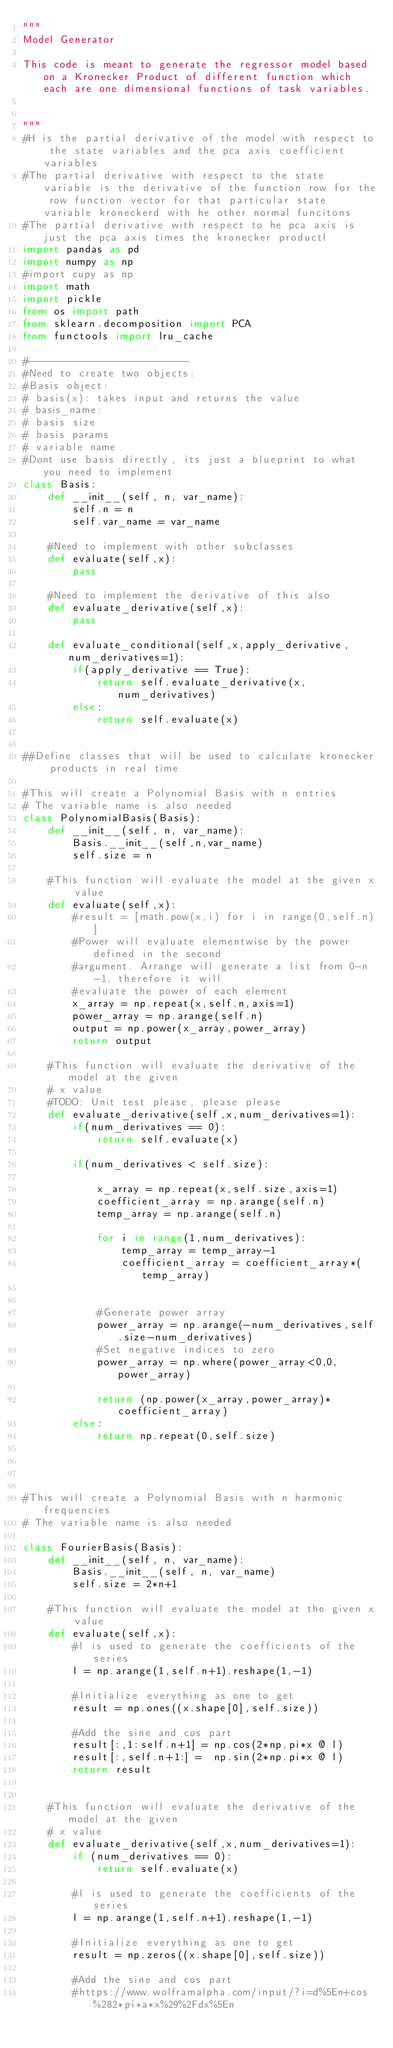Convert code to text. <code><loc_0><loc_0><loc_500><loc_500><_Python_>"""
Model Generator 

This code is meant to generate the regressor model based on a Kronecker Product of different function which each are one dimensional functions of task variables. 


"""
#H is the partial derivative of the model with respect to the state variables and the pca axis coefficient variables 
#The partial derivative with respect to the state variable is the derivative of the function row for the row function vector for that particular state variable kroneckerd with he other normal funcitons
#The partial derivative with respect to he pca axis is just the pca axis times the kronecker productl
import pandas as pd
import numpy as np
#import cupy as np
import math
import pickle
from os import path
from sklearn.decomposition import PCA
from functools import lru_cache

#--------------------------
#Need to create two objects:
#Basis object:
# basis(x): takes input and returns the value
# basis_name:
# basis size
# basis params
# variable name
#Dont use basis directly, its just a blueprint to what you need to implement
class Basis:
    def __init__(self, n, var_name):
        self.n = n
        self.var_name = var_name

    #Need to implement with other subclasses
    def evaluate(self,x):
        pass

    #Need to implement the derivative of this also
    def evaluate_derivative(self,x):
        pass

    def evaluate_conditional(self,x,apply_derivative,num_derivatives=1):
        if(apply_derivative == True):
            return self.evaluate_derivative(x,num_derivatives)
        else:
            return self.evaluate(x)


##Define classes that will be used to calculate kronecker products in real time

#This will create a Polynomial Basis with n entries
# The variable name is also needed
class PolynomialBasis(Basis):
    def __init__(self, n, var_name):
        Basis.__init__(self,n,var_name)
        self.size = n

    #This function will evaluate the model at the given x value
    def evaluate(self,x):
        #result = [math.pow(x,i) for i in range(0,self.n)]
        #Power will evaluate elementwise by the power defined in the second 
        #argument. Arrange will generate a list from 0-n-1, therefore it will 
        #evaluate the power of each element
        x_array = np.repeat(x,self.n,axis=1)
        power_array = np.arange(self.n)
        output = np.power(x_array,power_array)
        return output

    #This function will evaluate the derivative of the model at the given 
    # x value
    #TODO: Unit test please, please please
    def evaluate_derivative(self,x,num_derivatives=1):
        if(num_derivatives == 0):
            return self.evaluate(x)
        
        if(num_derivatives < self.size):
            
            x_array = np.repeat(x,self.size,axis=1)
            coefficient_array = np.arange(self.n)
            temp_array = np.arange(self.n)
            
            for i in range(1,num_derivatives):
                temp_array = temp_array-1
                coefficient_array = coefficient_array*(temp_array)
                
            
            #Generate power array
            power_array = np.arange(-num_derivatives,self.size-num_derivatives)
            #Set negative indices to zero
            power_array = np.where(power_array<0,0,power_array)
            
            return (np.power(x_array,power_array)*coefficient_array)
        else:
            return np.repeat(0,self.size)

         


#This will create a Polynomial Basis with n harmonic frequencies
# The variable name is also needed

class FourierBasis(Basis):
    def __init__(self, n, var_name):
        Basis.__init__(self, n, var_name)
        self.size = 2*n+1

    #This function will evaluate the model at the given x value
    def evaluate(self,x):
        #l is used to generate the coefficients of the series
        l = np.arange(1,self.n+1).reshape(1,-1)
        
        #Initialize everything as one to get 
        result = np.ones((x.shape[0],self.size))
       
        #Add the sine and cos part
        result[:,1:self.n+1] = np.cos(2*np.pi*x @ l)
        result[:,self.n+1:] =  np.sin(2*np.pi*x @ l)
        return result


    #This function will evaluate the derivative of the model at the given 
    # x value
    def evaluate_derivative(self,x,num_derivatives=1):
        if (num_derivatives == 0):
            return self.evaluate(x)
        
        #l is used to generate the coefficients of the series
        l = np.arange(1,self.n+1).reshape(1,-1)
        
        #Initialize everything as one to get 
        result = np.zeros((x.shape[0],self.size))
        
        #Add the sine and cos part
        #https://www.wolframalpha.com/input/?i=d%5En+cos%282*pi*a*x%29%2Fdx%5En</code> 